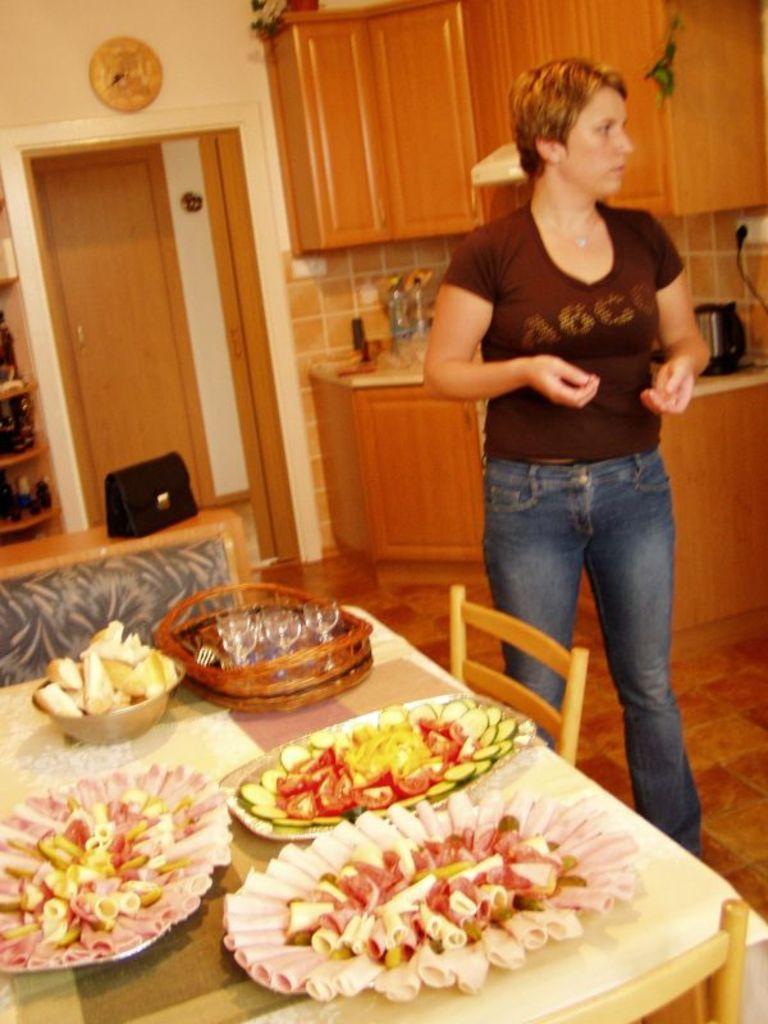In one or two sentences, can you explain what this image depicts? In this image in the front there is a table and on the table there is food and there are empty chairs. In the center there is a person standing. In the background there is a door and there is a wardrobe and there is a platform. On the platform there are objects and on the left side there is a shelf and in the shelf there are objects which are black in colour and there is a purse which is black in colour. 